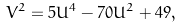Convert formula to latex. <formula><loc_0><loc_0><loc_500><loc_500>V ^ { 2 } = 5 U ^ { 4 } - 7 0 U ^ { 2 } + 4 9 ,</formula> 